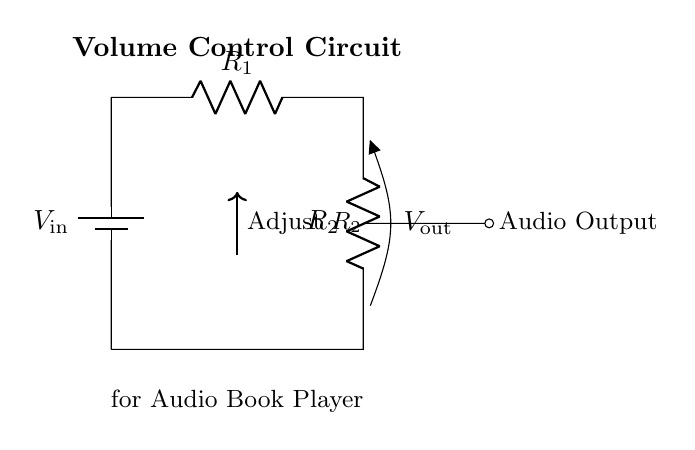What do the resistors in the circuit represent? The resistors, R1 and R2, are used to create a voltage divider, which adjusts the output voltage relative to the input voltage.
Answer: Adjust the output voltage What is the role of R2 in this volume control circuit? R2 is the adjustable resistor that helps to control the output voltage, allowing the user to change the volume of the audio output.
Answer: Control volume What is the voltage output when R2 is at its minimum setting? With R2 minimized (zero resistance), Vout will equal Vin, as all the input voltage drops across R1.
Answer: Vin How does increasing R2 affect the output voltage, Vout? Increasing R2 raises the total resistance in the circuit, which causes a larger portion of the input voltage to drop across R2, thus decreasing Vout.
Answer: Decrease Vout What type of circuit is depicted? The circuit depicted is a voltage divider circuit, which is specifically designed to divide the input voltage into a lower output voltage.
Answer: Voltage divider 